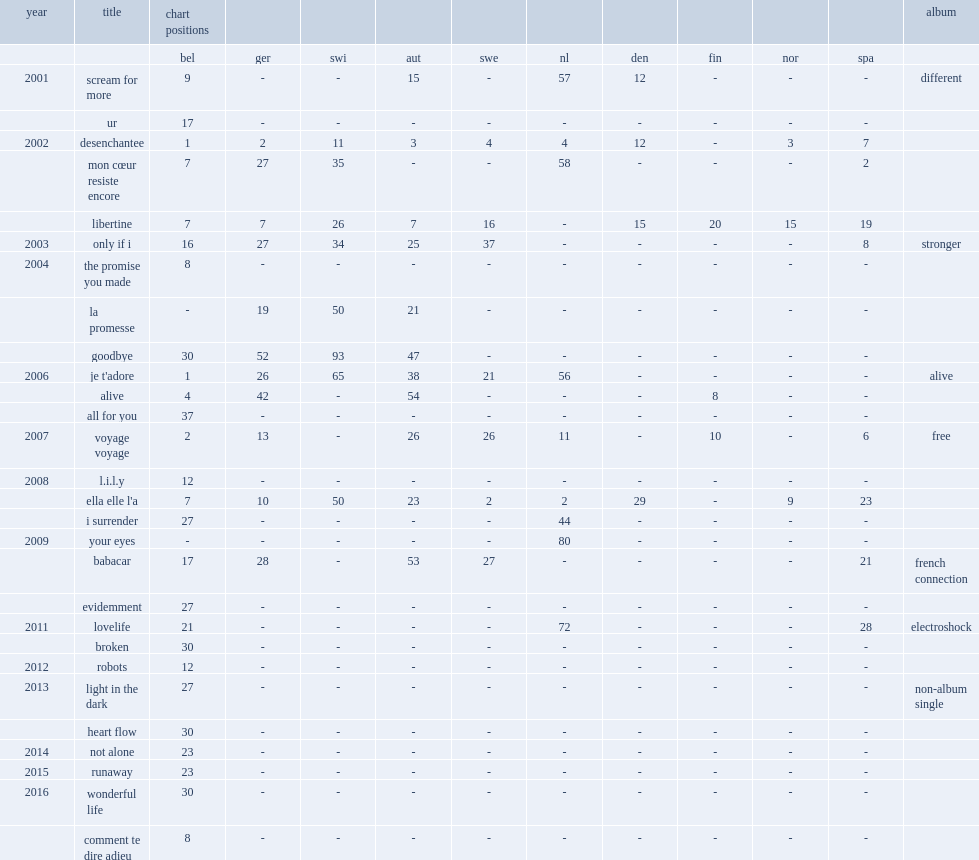Would you mind parsing the complete table? {'header': ['year', 'title', 'chart positions', '', '', '', '', '', '', '', '', '', 'album'], 'rows': [['', '', 'bel', 'ger', 'swi', 'aut', 'swe', 'nl', 'den', 'fin', 'nor', 'spa', ''], ['2001', 'scream for more', '9', '-', '-', '15', '-', '57', '12', '-', '-', '-', 'different'], ['', 'ur', '17', '-', '-', '-', '-', '-', '-', '-', '-', '-', ''], ['2002', 'desenchantee', '1', '2', '11', '3', '4', '4', '12', '-', '3', '7', ''], ['', 'mon cœur resiste encore', '7', '27', '35', '-', '-', '58', '-', '-', '-', '2', ''], ['', 'libertine', '7', '7', '26', '7', '16', '-', '15', '20', '15', '19', ''], ['2003', 'only if i', '16', '27', '34', '25', '37', '-', '-', '-', '-', '8', 'stronger'], ['2004', 'the promise you made', '8', '-', '-', '-', '-', '-', '-', '-', '-', '-', ''], ['', 'la promesse', '-', '19', '50', '21', '-', '-', '-', '-', '-', '-', ''], ['', 'goodbye', '30', '52', '93', '47', '-', '-', '-', '-', '-', '-', ''], ['2006', "je t'adore", '1', '26', '65', '38', '21', '56', '-', '-', '-', '-', 'alive'], ['', 'alive', '4', '42', '-', '54', '-', '-', '-', '8', '-', '-', ''], ['', 'all for you', '37', '-', '-', '-', '-', '-', '-', '-', '-', '-', ''], ['2007', 'voyage voyage', '2', '13', '-', '26', '26', '11', '-', '10', '-', '6', 'free'], ['2008', 'l.i.l.y', '12', '-', '-', '-', '-', '-', '-', '-', '-', '-', ''], ['', "ella elle l'a", '7', '10', '50', '23', '2', '2', '29', '-', '9', '23', ''], ['', 'i surrender', '27', '-', '-', '-', '-', '44', '-', '-', '-', '-', ''], ['2009', 'your eyes', '-', '-', '-', '-', '-', '80', '-', '-', '-', '-', ''], ['', 'babacar', '17', '28', '-', '53', '27', '-', '-', '-', '-', '21', 'french connection'], ['', 'evidemment', '27', '-', '-', '-', '-', '-', '-', '-', '-', '-', ''], ['2011', 'lovelife', '21', '-', '-', '-', '-', '72', '-', '-', '-', '28', 'electroshock'], ['', 'broken', '30', '-', '-', '-', '-', '-', '-', '-', '-', '-', ''], ['2012', 'robots', '12', '-', '-', '-', '-', '-', '-', '-', '-', '-', ''], ['2013', 'light in the dark', '27', '-', '-', '-', '-', '-', '-', '-', '-', '-', 'non-album single'], ['', 'heart flow', '30', '-', '-', '-', '-', '-', '-', '-', '-', '-', ''], ['2014', 'not alone', '23', '-', '-', '-', '-', '-', '-', '-', '-', '-', ''], ['2015', 'runaway', '23', '-', '-', '-', '-', '-', '-', '-', '-', '-', ''], ['2016', 'wonderful life', '30', '-', '-', '-', '-', '-', '-', '-', '-', '-', ''], ['', 'comment te dire adieu', '8', '-', '-', '-', '-', '-', '-', '-', '-', '-', '']]} In 2012, which album did ryan release single "robots" from? Electroshock. 